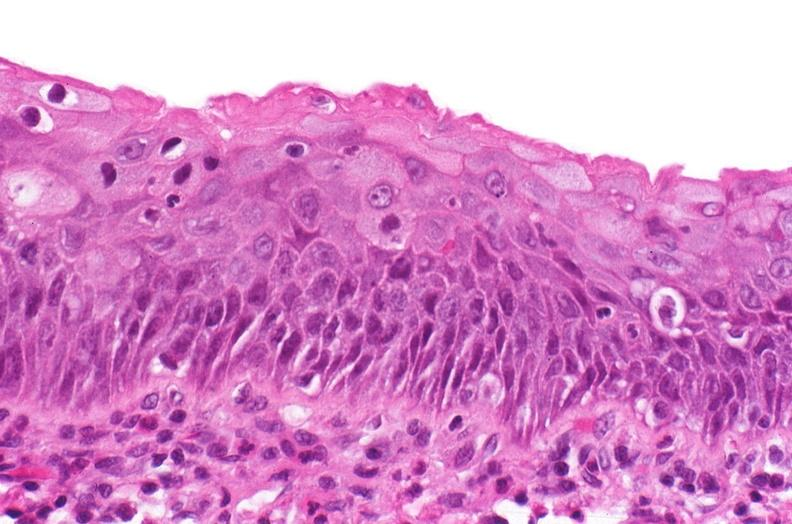what does this image show?
Answer the question using a single word or phrase. Renal pelvis 